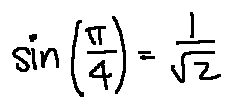Convert formula to latex. <formula><loc_0><loc_0><loc_500><loc_500>\sin ( \frac { \pi } { 4 } ) = \frac { 1 } { \sqrt { 2 } }</formula> 